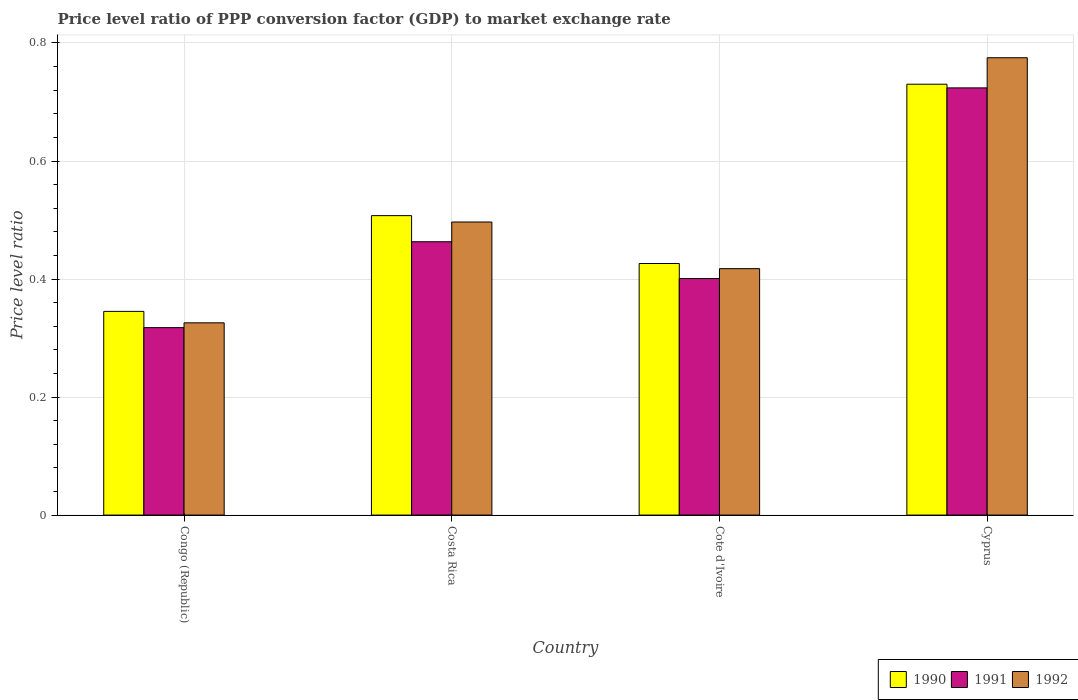How many different coloured bars are there?
Provide a short and direct response. 3. How many groups of bars are there?
Provide a succinct answer. 4. Are the number of bars per tick equal to the number of legend labels?
Give a very brief answer. Yes. How many bars are there on the 4th tick from the left?
Offer a terse response. 3. How many bars are there on the 2nd tick from the right?
Your answer should be compact. 3. What is the label of the 1st group of bars from the left?
Your response must be concise. Congo (Republic). What is the price level ratio in 1990 in Cyprus?
Your answer should be very brief. 0.73. Across all countries, what is the maximum price level ratio in 1992?
Provide a succinct answer. 0.77. Across all countries, what is the minimum price level ratio in 1990?
Offer a very short reply. 0.35. In which country was the price level ratio in 1992 maximum?
Your response must be concise. Cyprus. In which country was the price level ratio in 1992 minimum?
Your response must be concise. Congo (Republic). What is the total price level ratio in 1992 in the graph?
Your answer should be very brief. 2.01. What is the difference between the price level ratio in 1992 in Costa Rica and that in Cote d'Ivoire?
Offer a terse response. 0.08. What is the difference between the price level ratio in 1991 in Cyprus and the price level ratio in 1992 in Costa Rica?
Ensure brevity in your answer.  0.23. What is the average price level ratio in 1991 per country?
Offer a terse response. 0.48. What is the difference between the price level ratio of/in 1992 and price level ratio of/in 1991 in Costa Rica?
Offer a terse response. 0.03. In how many countries, is the price level ratio in 1992 greater than 0.08?
Offer a very short reply. 4. What is the ratio of the price level ratio in 1992 in Cote d'Ivoire to that in Cyprus?
Offer a terse response. 0.54. What is the difference between the highest and the second highest price level ratio in 1990?
Provide a succinct answer. 0.22. What is the difference between the highest and the lowest price level ratio in 1990?
Provide a succinct answer. 0.38. What does the 3rd bar from the left in Congo (Republic) represents?
Offer a very short reply. 1992. Is it the case that in every country, the sum of the price level ratio in 1991 and price level ratio in 1992 is greater than the price level ratio in 1990?
Your response must be concise. Yes. Are all the bars in the graph horizontal?
Provide a short and direct response. No. How many countries are there in the graph?
Provide a short and direct response. 4. Are the values on the major ticks of Y-axis written in scientific E-notation?
Make the answer very short. No. Does the graph contain any zero values?
Keep it short and to the point. No. Does the graph contain grids?
Ensure brevity in your answer.  Yes. Where does the legend appear in the graph?
Your answer should be very brief. Bottom right. How are the legend labels stacked?
Give a very brief answer. Horizontal. What is the title of the graph?
Ensure brevity in your answer.  Price level ratio of PPP conversion factor (GDP) to market exchange rate. What is the label or title of the X-axis?
Keep it short and to the point. Country. What is the label or title of the Y-axis?
Give a very brief answer. Price level ratio. What is the Price level ratio in 1990 in Congo (Republic)?
Your response must be concise. 0.35. What is the Price level ratio of 1991 in Congo (Republic)?
Offer a very short reply. 0.32. What is the Price level ratio in 1992 in Congo (Republic)?
Offer a very short reply. 0.33. What is the Price level ratio of 1990 in Costa Rica?
Offer a very short reply. 0.51. What is the Price level ratio of 1991 in Costa Rica?
Give a very brief answer. 0.46. What is the Price level ratio in 1992 in Costa Rica?
Provide a succinct answer. 0.5. What is the Price level ratio of 1990 in Cote d'Ivoire?
Keep it short and to the point. 0.43. What is the Price level ratio of 1991 in Cote d'Ivoire?
Your response must be concise. 0.4. What is the Price level ratio in 1992 in Cote d'Ivoire?
Ensure brevity in your answer.  0.42. What is the Price level ratio of 1990 in Cyprus?
Offer a very short reply. 0.73. What is the Price level ratio of 1991 in Cyprus?
Give a very brief answer. 0.72. What is the Price level ratio in 1992 in Cyprus?
Offer a terse response. 0.77. Across all countries, what is the maximum Price level ratio in 1990?
Ensure brevity in your answer.  0.73. Across all countries, what is the maximum Price level ratio of 1991?
Keep it short and to the point. 0.72. Across all countries, what is the maximum Price level ratio in 1992?
Your response must be concise. 0.77. Across all countries, what is the minimum Price level ratio of 1990?
Keep it short and to the point. 0.35. Across all countries, what is the minimum Price level ratio of 1991?
Your response must be concise. 0.32. Across all countries, what is the minimum Price level ratio of 1992?
Make the answer very short. 0.33. What is the total Price level ratio of 1990 in the graph?
Your response must be concise. 2.01. What is the total Price level ratio in 1991 in the graph?
Provide a succinct answer. 1.91. What is the total Price level ratio in 1992 in the graph?
Give a very brief answer. 2.02. What is the difference between the Price level ratio in 1990 in Congo (Republic) and that in Costa Rica?
Offer a very short reply. -0.16. What is the difference between the Price level ratio in 1991 in Congo (Republic) and that in Costa Rica?
Provide a short and direct response. -0.15. What is the difference between the Price level ratio of 1992 in Congo (Republic) and that in Costa Rica?
Ensure brevity in your answer.  -0.17. What is the difference between the Price level ratio in 1990 in Congo (Republic) and that in Cote d'Ivoire?
Provide a succinct answer. -0.08. What is the difference between the Price level ratio in 1991 in Congo (Republic) and that in Cote d'Ivoire?
Provide a short and direct response. -0.08. What is the difference between the Price level ratio in 1992 in Congo (Republic) and that in Cote d'Ivoire?
Provide a succinct answer. -0.09. What is the difference between the Price level ratio in 1990 in Congo (Republic) and that in Cyprus?
Provide a short and direct response. -0.39. What is the difference between the Price level ratio in 1991 in Congo (Republic) and that in Cyprus?
Offer a terse response. -0.41. What is the difference between the Price level ratio in 1992 in Congo (Republic) and that in Cyprus?
Offer a terse response. -0.45. What is the difference between the Price level ratio in 1990 in Costa Rica and that in Cote d'Ivoire?
Provide a succinct answer. 0.08. What is the difference between the Price level ratio of 1991 in Costa Rica and that in Cote d'Ivoire?
Ensure brevity in your answer.  0.06. What is the difference between the Price level ratio in 1992 in Costa Rica and that in Cote d'Ivoire?
Provide a short and direct response. 0.08. What is the difference between the Price level ratio in 1990 in Costa Rica and that in Cyprus?
Provide a short and direct response. -0.22. What is the difference between the Price level ratio of 1991 in Costa Rica and that in Cyprus?
Offer a very short reply. -0.26. What is the difference between the Price level ratio in 1992 in Costa Rica and that in Cyprus?
Make the answer very short. -0.28. What is the difference between the Price level ratio of 1990 in Cote d'Ivoire and that in Cyprus?
Ensure brevity in your answer.  -0.3. What is the difference between the Price level ratio in 1991 in Cote d'Ivoire and that in Cyprus?
Offer a terse response. -0.32. What is the difference between the Price level ratio of 1992 in Cote d'Ivoire and that in Cyprus?
Offer a very short reply. -0.36. What is the difference between the Price level ratio of 1990 in Congo (Republic) and the Price level ratio of 1991 in Costa Rica?
Offer a very short reply. -0.12. What is the difference between the Price level ratio in 1990 in Congo (Republic) and the Price level ratio in 1992 in Costa Rica?
Ensure brevity in your answer.  -0.15. What is the difference between the Price level ratio of 1991 in Congo (Republic) and the Price level ratio of 1992 in Costa Rica?
Offer a very short reply. -0.18. What is the difference between the Price level ratio of 1990 in Congo (Republic) and the Price level ratio of 1991 in Cote d'Ivoire?
Ensure brevity in your answer.  -0.06. What is the difference between the Price level ratio in 1990 in Congo (Republic) and the Price level ratio in 1992 in Cote d'Ivoire?
Make the answer very short. -0.07. What is the difference between the Price level ratio of 1990 in Congo (Republic) and the Price level ratio of 1991 in Cyprus?
Give a very brief answer. -0.38. What is the difference between the Price level ratio in 1990 in Congo (Republic) and the Price level ratio in 1992 in Cyprus?
Your answer should be compact. -0.43. What is the difference between the Price level ratio of 1991 in Congo (Republic) and the Price level ratio of 1992 in Cyprus?
Offer a very short reply. -0.46. What is the difference between the Price level ratio in 1990 in Costa Rica and the Price level ratio in 1991 in Cote d'Ivoire?
Offer a terse response. 0.11. What is the difference between the Price level ratio in 1990 in Costa Rica and the Price level ratio in 1992 in Cote d'Ivoire?
Your response must be concise. 0.09. What is the difference between the Price level ratio of 1991 in Costa Rica and the Price level ratio of 1992 in Cote d'Ivoire?
Ensure brevity in your answer.  0.05. What is the difference between the Price level ratio of 1990 in Costa Rica and the Price level ratio of 1991 in Cyprus?
Give a very brief answer. -0.22. What is the difference between the Price level ratio of 1990 in Costa Rica and the Price level ratio of 1992 in Cyprus?
Your response must be concise. -0.27. What is the difference between the Price level ratio of 1991 in Costa Rica and the Price level ratio of 1992 in Cyprus?
Your response must be concise. -0.31. What is the difference between the Price level ratio in 1990 in Cote d'Ivoire and the Price level ratio in 1991 in Cyprus?
Your answer should be very brief. -0.3. What is the difference between the Price level ratio in 1990 in Cote d'Ivoire and the Price level ratio in 1992 in Cyprus?
Make the answer very short. -0.35. What is the difference between the Price level ratio of 1991 in Cote d'Ivoire and the Price level ratio of 1992 in Cyprus?
Keep it short and to the point. -0.37. What is the average Price level ratio in 1990 per country?
Make the answer very short. 0.5. What is the average Price level ratio in 1991 per country?
Your answer should be compact. 0.48. What is the average Price level ratio of 1992 per country?
Provide a succinct answer. 0.5. What is the difference between the Price level ratio of 1990 and Price level ratio of 1991 in Congo (Republic)?
Make the answer very short. 0.03. What is the difference between the Price level ratio in 1990 and Price level ratio in 1992 in Congo (Republic)?
Provide a succinct answer. 0.02. What is the difference between the Price level ratio in 1991 and Price level ratio in 1992 in Congo (Republic)?
Offer a terse response. -0.01. What is the difference between the Price level ratio of 1990 and Price level ratio of 1991 in Costa Rica?
Provide a succinct answer. 0.04. What is the difference between the Price level ratio of 1990 and Price level ratio of 1992 in Costa Rica?
Your answer should be very brief. 0.01. What is the difference between the Price level ratio in 1991 and Price level ratio in 1992 in Costa Rica?
Ensure brevity in your answer.  -0.03. What is the difference between the Price level ratio in 1990 and Price level ratio in 1991 in Cote d'Ivoire?
Provide a short and direct response. 0.03. What is the difference between the Price level ratio of 1990 and Price level ratio of 1992 in Cote d'Ivoire?
Your answer should be compact. 0.01. What is the difference between the Price level ratio in 1991 and Price level ratio in 1992 in Cote d'Ivoire?
Your response must be concise. -0.02. What is the difference between the Price level ratio of 1990 and Price level ratio of 1991 in Cyprus?
Provide a short and direct response. 0.01. What is the difference between the Price level ratio of 1990 and Price level ratio of 1992 in Cyprus?
Give a very brief answer. -0.04. What is the difference between the Price level ratio of 1991 and Price level ratio of 1992 in Cyprus?
Provide a succinct answer. -0.05. What is the ratio of the Price level ratio in 1990 in Congo (Republic) to that in Costa Rica?
Offer a very short reply. 0.68. What is the ratio of the Price level ratio of 1991 in Congo (Republic) to that in Costa Rica?
Your answer should be compact. 0.69. What is the ratio of the Price level ratio of 1992 in Congo (Republic) to that in Costa Rica?
Give a very brief answer. 0.66. What is the ratio of the Price level ratio in 1990 in Congo (Republic) to that in Cote d'Ivoire?
Your answer should be very brief. 0.81. What is the ratio of the Price level ratio in 1991 in Congo (Republic) to that in Cote d'Ivoire?
Make the answer very short. 0.79. What is the ratio of the Price level ratio of 1992 in Congo (Republic) to that in Cote d'Ivoire?
Your answer should be very brief. 0.78. What is the ratio of the Price level ratio of 1990 in Congo (Republic) to that in Cyprus?
Make the answer very short. 0.47. What is the ratio of the Price level ratio of 1991 in Congo (Republic) to that in Cyprus?
Provide a succinct answer. 0.44. What is the ratio of the Price level ratio of 1992 in Congo (Republic) to that in Cyprus?
Make the answer very short. 0.42. What is the ratio of the Price level ratio of 1990 in Costa Rica to that in Cote d'Ivoire?
Keep it short and to the point. 1.19. What is the ratio of the Price level ratio of 1991 in Costa Rica to that in Cote d'Ivoire?
Your answer should be compact. 1.16. What is the ratio of the Price level ratio of 1992 in Costa Rica to that in Cote d'Ivoire?
Give a very brief answer. 1.19. What is the ratio of the Price level ratio in 1990 in Costa Rica to that in Cyprus?
Provide a short and direct response. 0.69. What is the ratio of the Price level ratio of 1991 in Costa Rica to that in Cyprus?
Keep it short and to the point. 0.64. What is the ratio of the Price level ratio in 1992 in Costa Rica to that in Cyprus?
Ensure brevity in your answer.  0.64. What is the ratio of the Price level ratio of 1990 in Cote d'Ivoire to that in Cyprus?
Your answer should be very brief. 0.58. What is the ratio of the Price level ratio in 1991 in Cote d'Ivoire to that in Cyprus?
Provide a short and direct response. 0.55. What is the ratio of the Price level ratio of 1992 in Cote d'Ivoire to that in Cyprus?
Ensure brevity in your answer.  0.54. What is the difference between the highest and the second highest Price level ratio of 1990?
Make the answer very short. 0.22. What is the difference between the highest and the second highest Price level ratio in 1991?
Ensure brevity in your answer.  0.26. What is the difference between the highest and the second highest Price level ratio in 1992?
Your response must be concise. 0.28. What is the difference between the highest and the lowest Price level ratio of 1990?
Your answer should be very brief. 0.39. What is the difference between the highest and the lowest Price level ratio of 1991?
Give a very brief answer. 0.41. What is the difference between the highest and the lowest Price level ratio of 1992?
Offer a terse response. 0.45. 